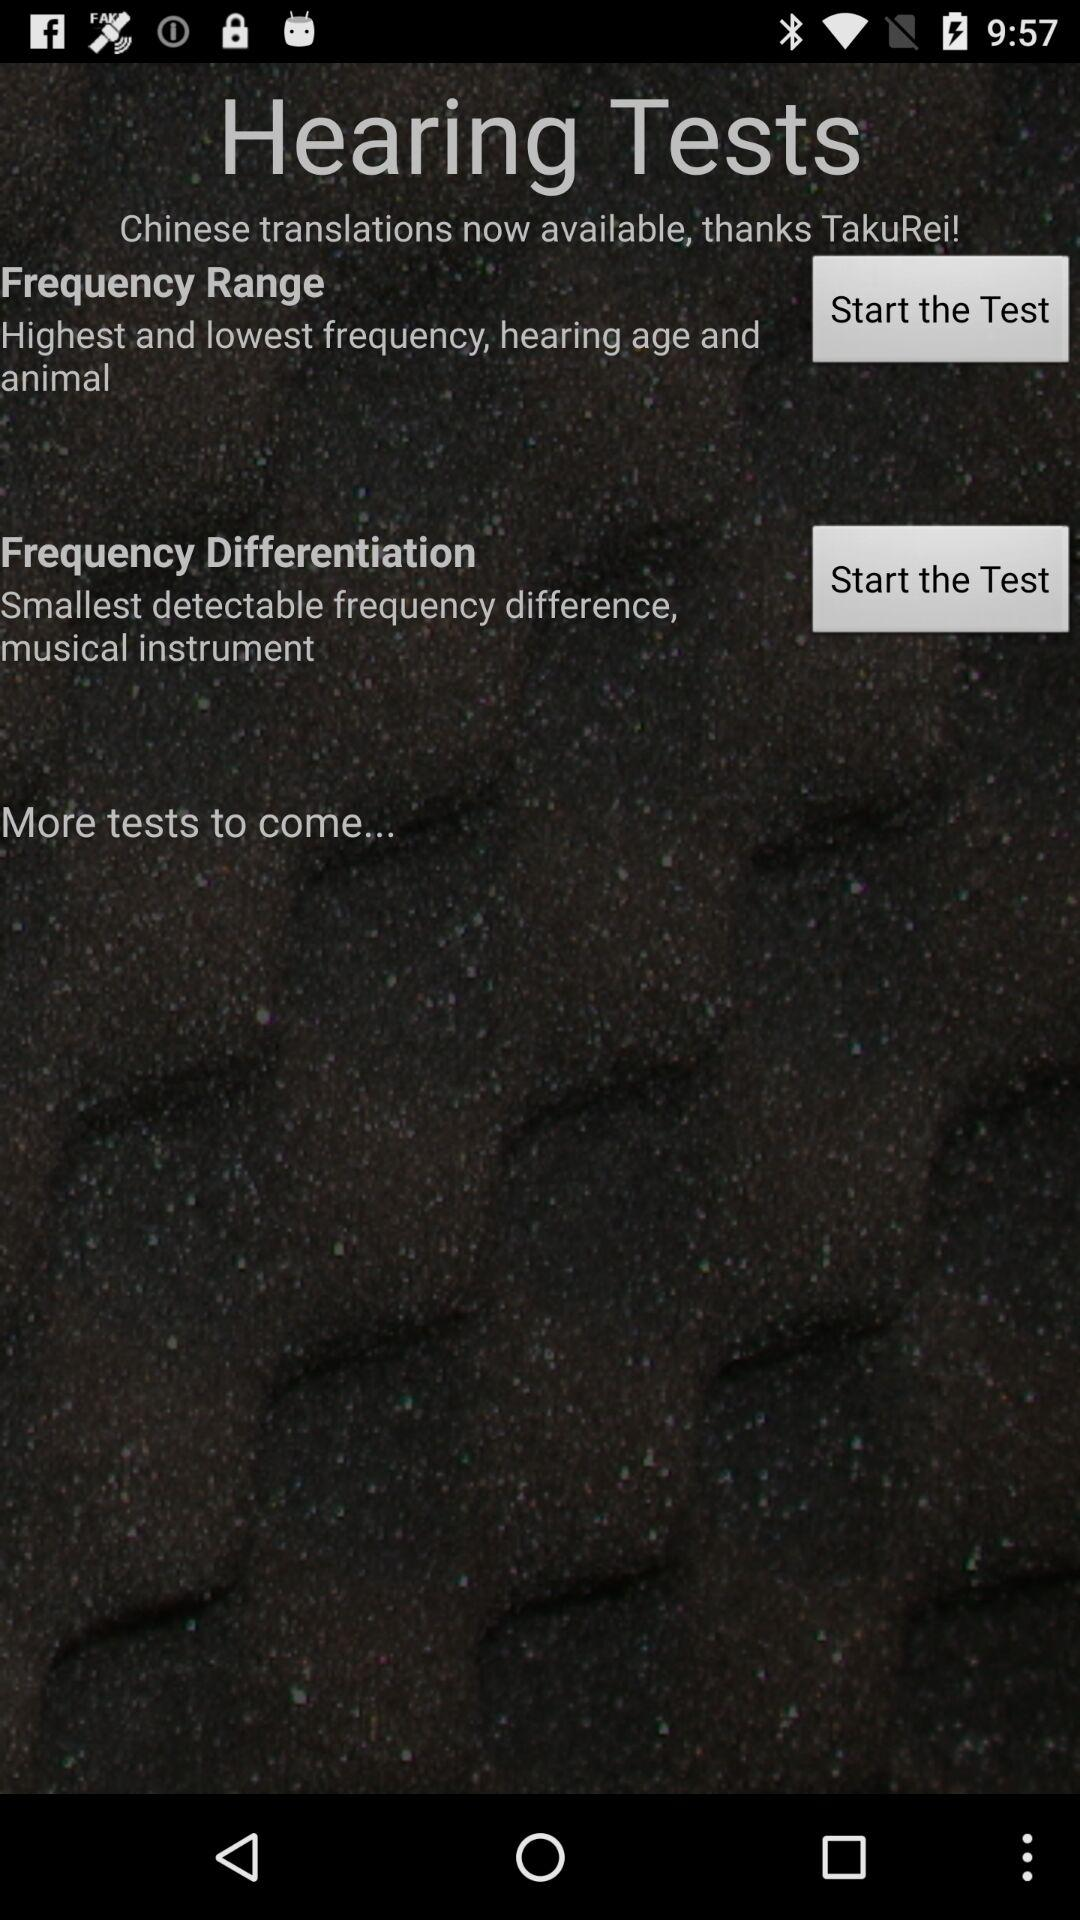What is the application name? The application name is "Hearing Tests". 